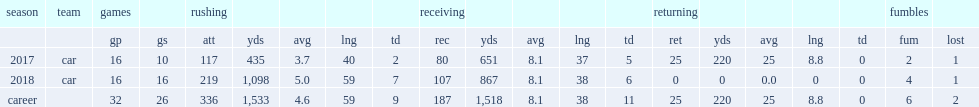How many rushing yards did christian mccaffrey finish the 2018 season with? 1098.0. 